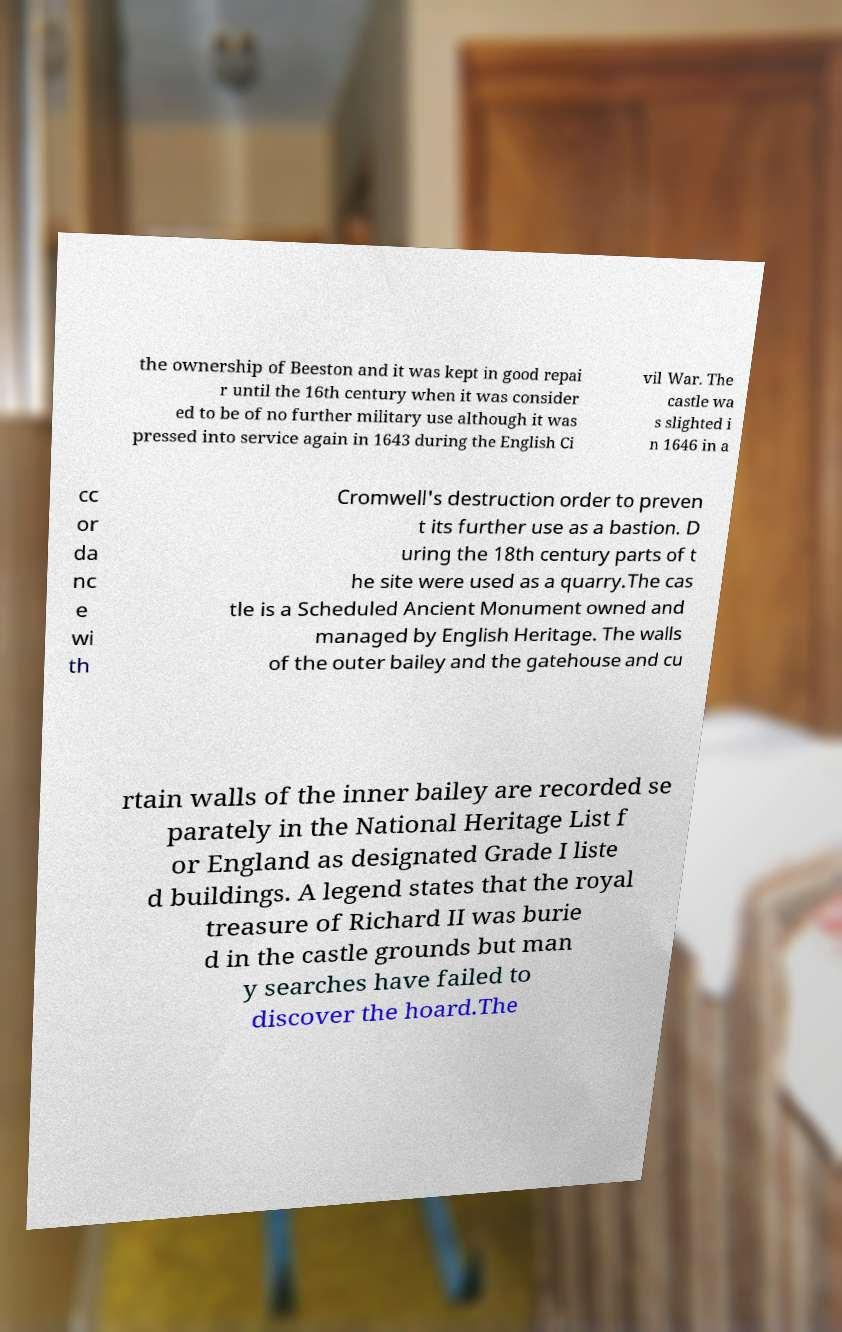There's text embedded in this image that I need extracted. Can you transcribe it verbatim? the ownership of Beeston and it was kept in good repai r until the 16th century when it was consider ed to be of no further military use although it was pressed into service again in 1643 during the English Ci vil War. The castle wa s slighted i n 1646 in a cc or da nc e wi th Cromwell's destruction order to preven t its further use as a bastion. D uring the 18th century parts of t he site were used as a quarry.The cas tle is a Scheduled Ancient Monument owned and managed by English Heritage. The walls of the outer bailey and the gatehouse and cu rtain walls of the inner bailey are recorded se parately in the National Heritage List f or England as designated Grade I liste d buildings. A legend states that the royal treasure of Richard II was burie d in the castle grounds but man y searches have failed to discover the hoard.The 